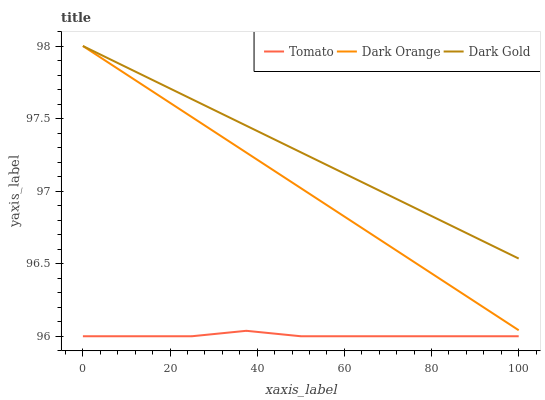Does Dark Orange have the minimum area under the curve?
Answer yes or no. No. Does Dark Orange have the maximum area under the curve?
Answer yes or no. No. Is Dark Orange the smoothest?
Answer yes or no. No. Is Dark Orange the roughest?
Answer yes or no. No. Does Dark Orange have the lowest value?
Answer yes or no. No. Is Tomato less than Dark Orange?
Answer yes or no. Yes. Is Dark Orange greater than Tomato?
Answer yes or no. Yes. Does Tomato intersect Dark Orange?
Answer yes or no. No. 